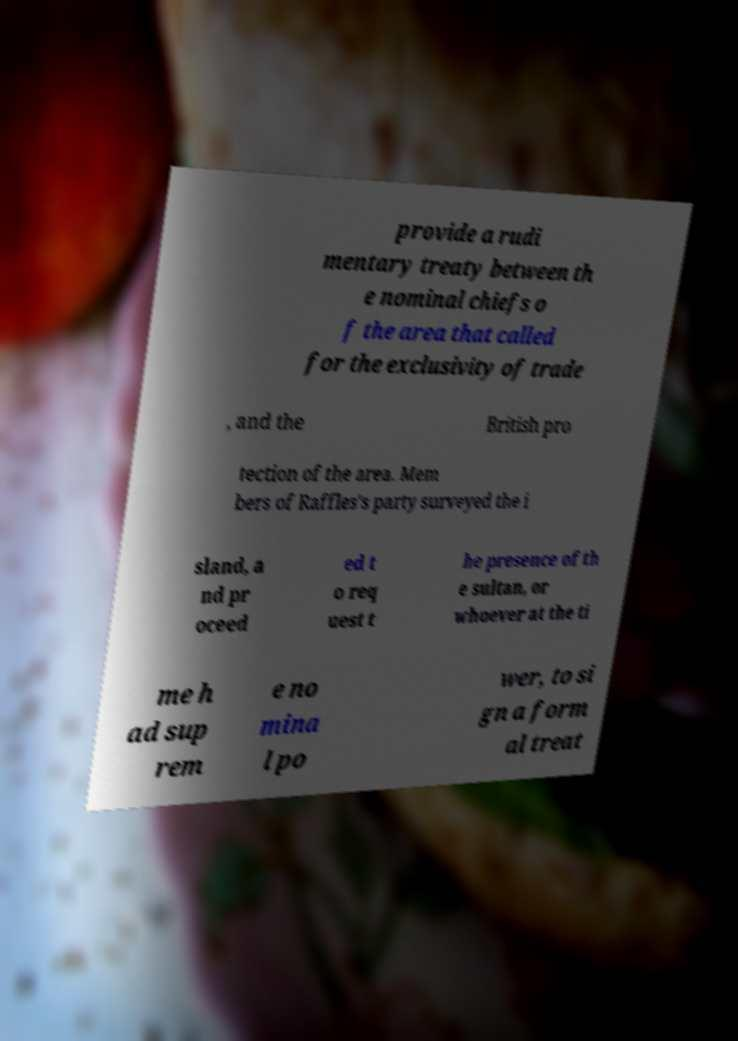I need the written content from this picture converted into text. Can you do that? provide a rudi mentary treaty between th e nominal chiefs o f the area that called for the exclusivity of trade , and the British pro tection of the area. Mem bers of Raffles's party surveyed the i sland, a nd pr oceed ed t o req uest t he presence of th e sultan, or whoever at the ti me h ad sup rem e no mina l po wer, to si gn a form al treat 